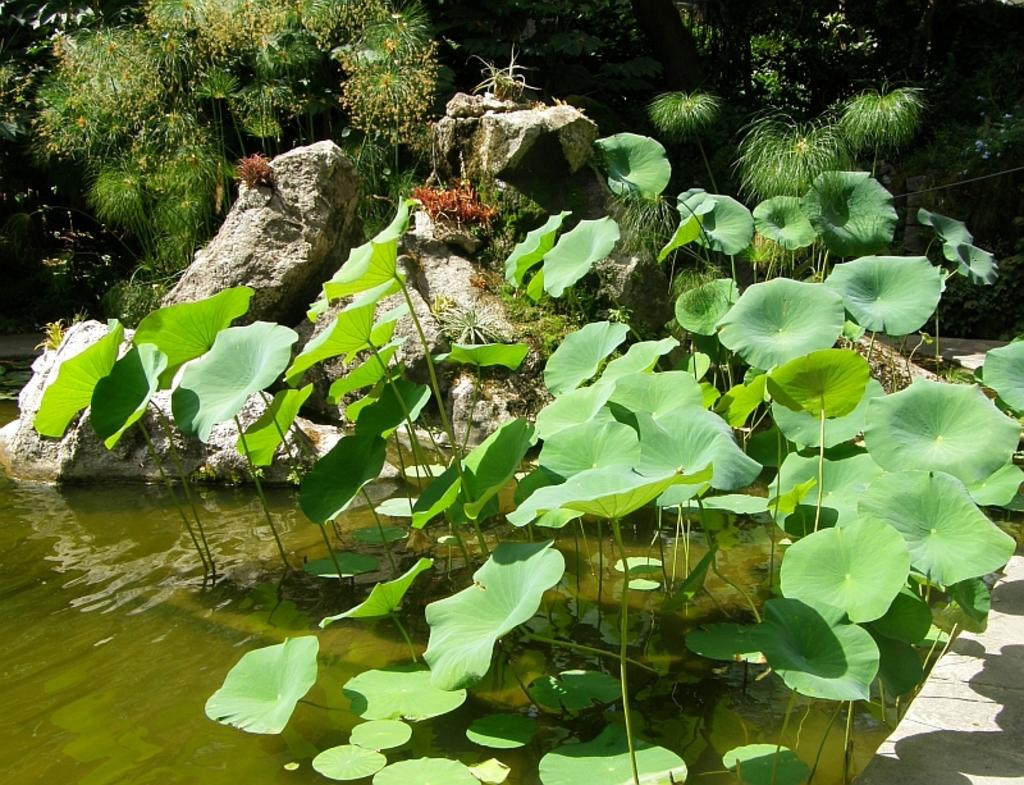What color are the leaves in the image? The leaves in the image are green. What can be seen besides the leaves in the image? Water is visible in the image. What is present in the background of the image? There are green color plants in the background of the image. Can you hear the frog croaking in the image? There is no frog present in the image, so it is not possible to hear any croaking. 